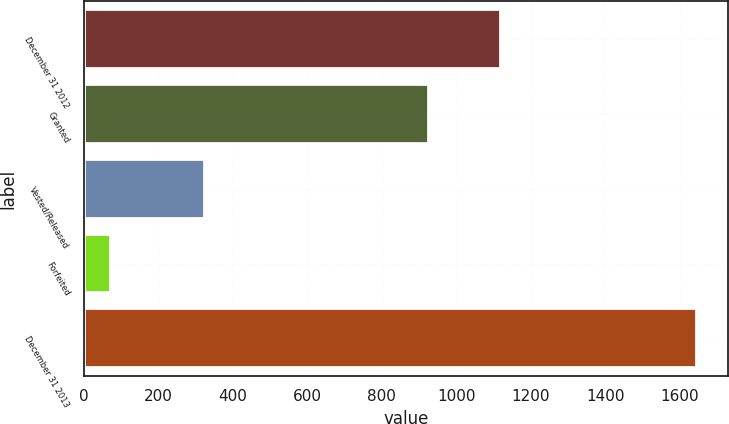Convert chart to OTSL. <chart><loc_0><loc_0><loc_500><loc_500><bar_chart><fcel>December 31 2012<fcel>Granted<fcel>Vested/Released<fcel>Forfeited<fcel>December 31 2013<nl><fcel>1119<fcel>926<fcel>326<fcel>72<fcel>1647<nl></chart> 